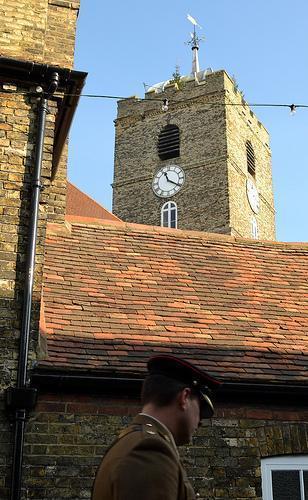How many men are there?
Give a very brief answer. 1. 